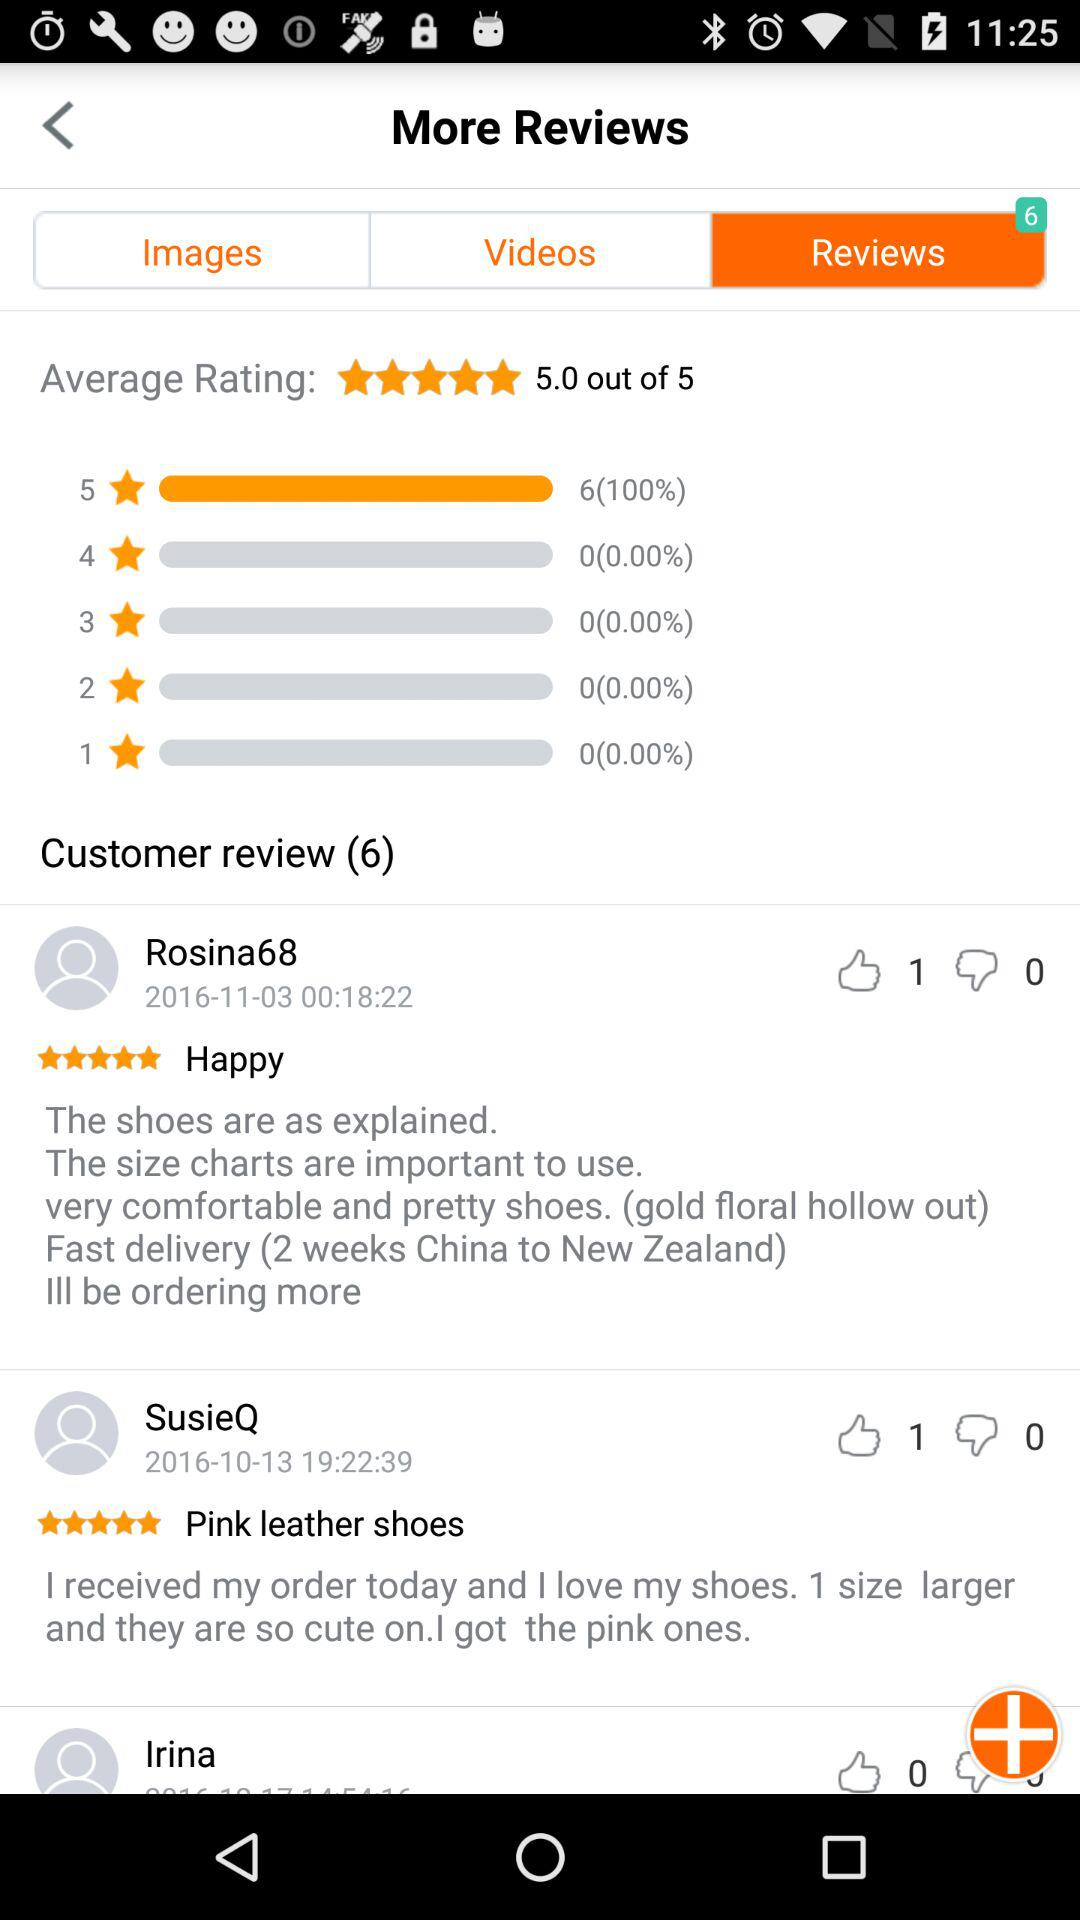How many likes did the review by "SusieQ" get? The number of likes the review by "SusieQ" got is 1. 